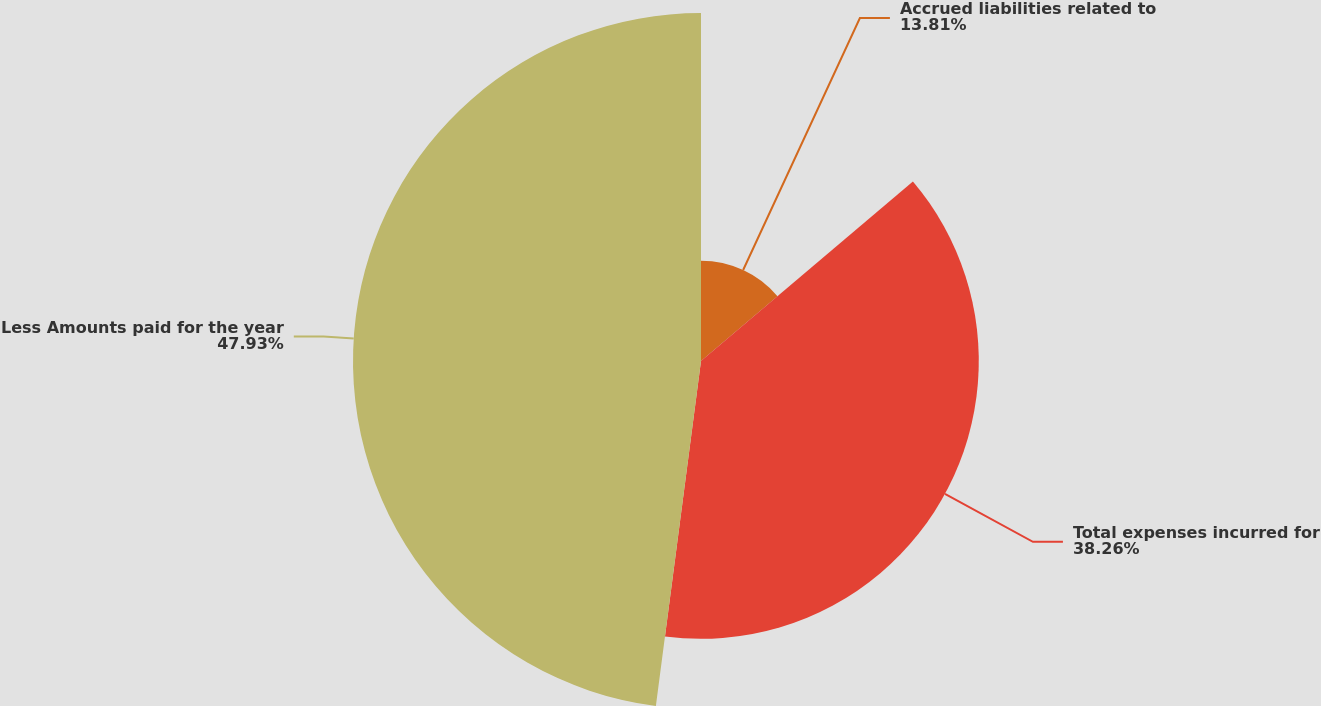<chart> <loc_0><loc_0><loc_500><loc_500><pie_chart><fcel>Accrued liabilities related to<fcel>Total expenses incurred for<fcel>Less Amounts paid for the year<nl><fcel>13.81%<fcel>38.26%<fcel>47.93%<nl></chart> 